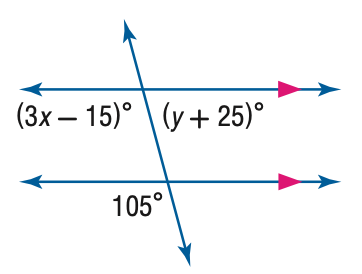Question: Find the value of the variable x in the figure.
Choices:
A. 30
B. 40
C. 50
D. 60
Answer with the letter. Answer: B 